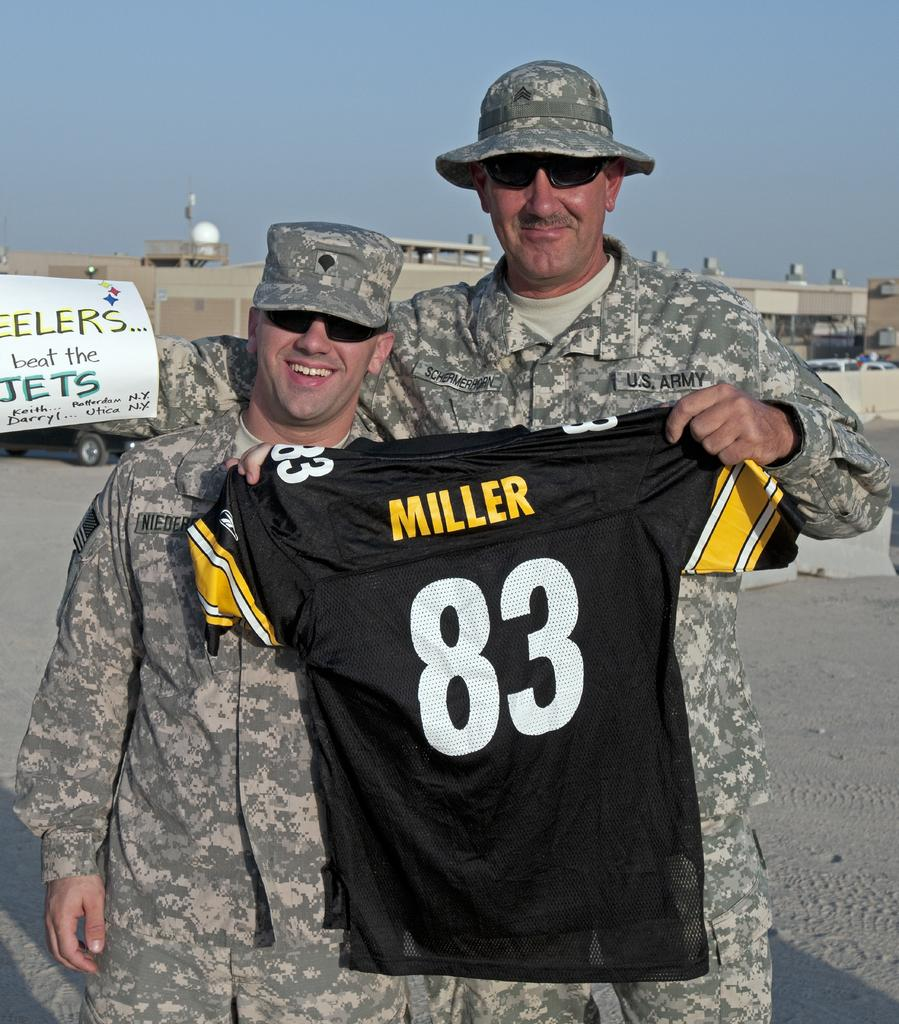Provide a one-sentence caption for the provided image. two men from the U.S. army holding up a number 83 miller jersey. 